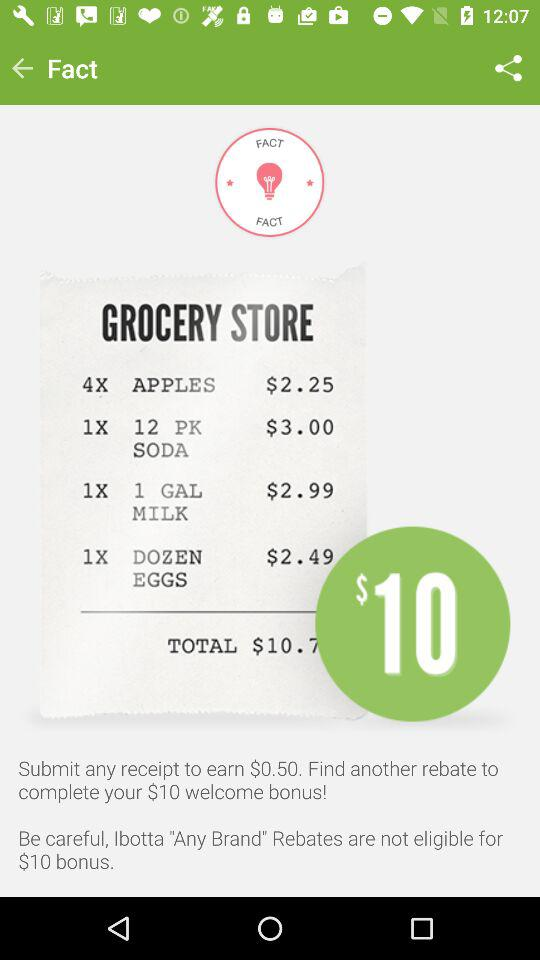What is the total price for the Grocery Store?
When the provided information is insufficient, respond with <no answer>. <no answer> 